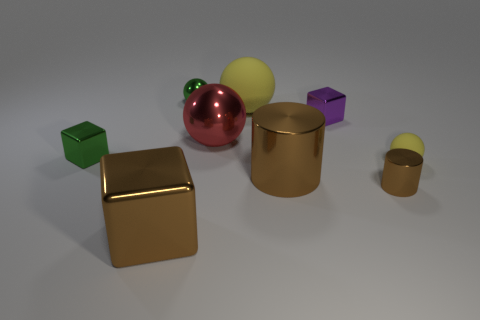Subtract all brown balls. Subtract all green cylinders. How many balls are left? 4 Add 1 green shiny cubes. How many objects exist? 10 Subtract all cubes. How many objects are left? 6 Add 4 small blue cylinders. How many small blue cylinders exist? 4 Subtract 0 blue cubes. How many objects are left? 9 Subtract all brown metal objects. Subtract all big brown metal objects. How many objects are left? 4 Add 6 big brown objects. How many big brown objects are left? 8 